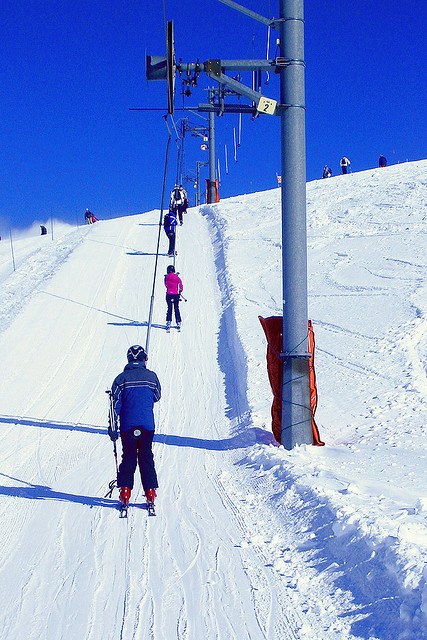Identify and read out the text in this image. 2 